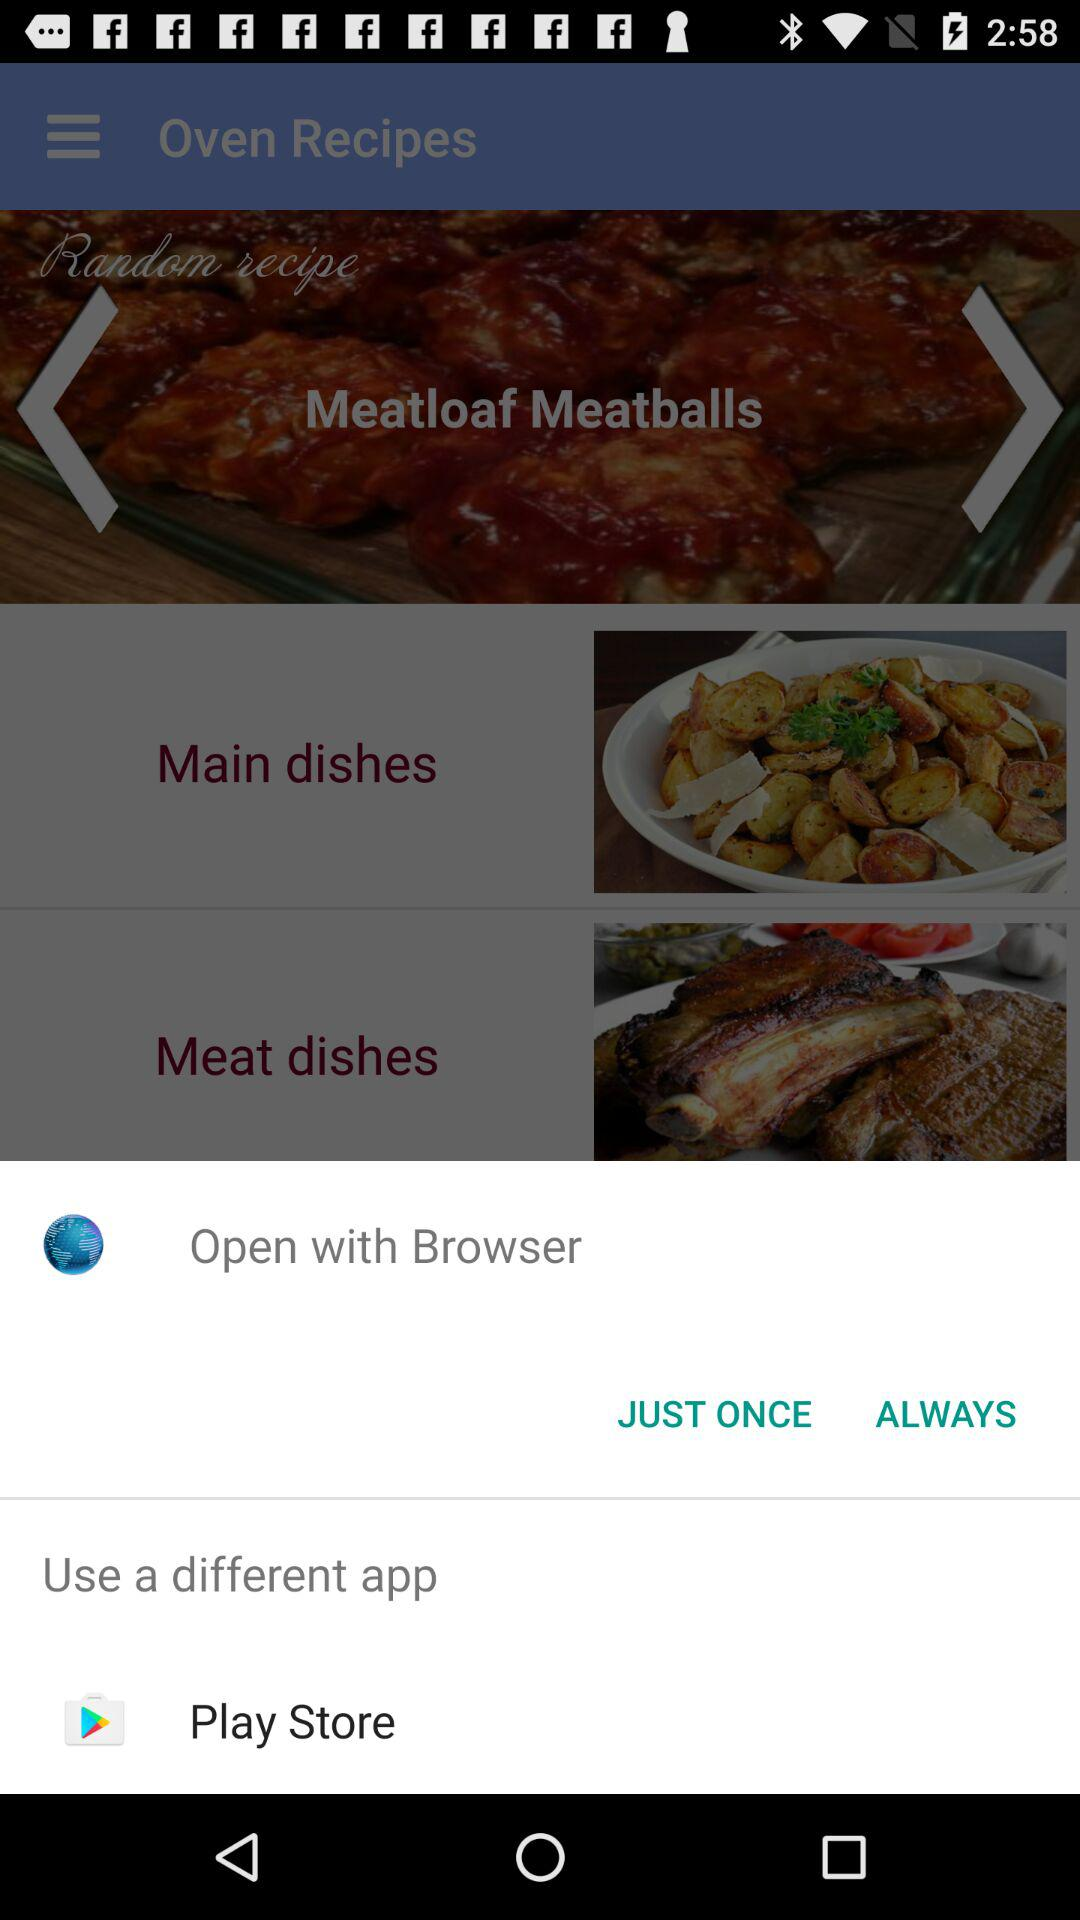What is the name of the different app? The name of the different app is "Play Store". 